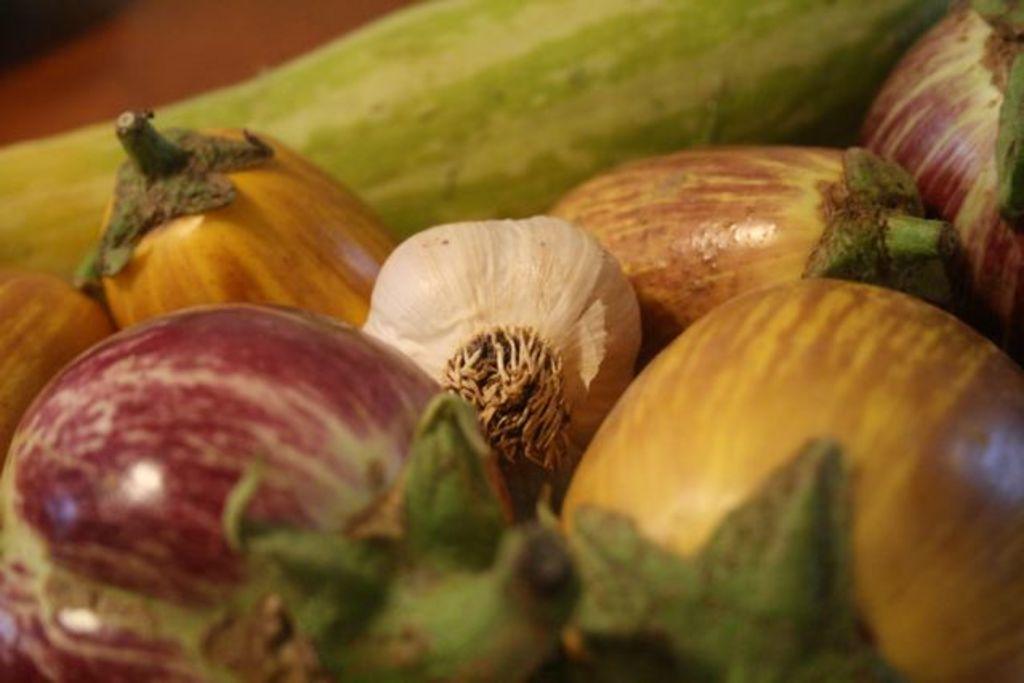Can you describe this image briefly? As we can see in the image there are cucumbers, onion and bottle gourd. 